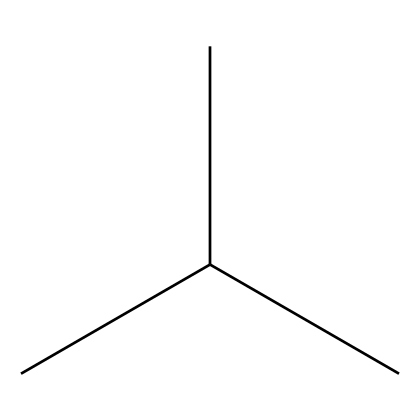What is the name of the chemical with the SMILES CC(C)C? The SMILES notation CC(C)C represents isobutane, which is a branched-chain alkane.
Answer: isobutane How many carbon atoms are in isobutane? The structure CC(C)C shows there are four carbon atoms when you count each "C" in the notation.
Answer: 4 What is the total number of hydrogen atoms in isobutane? Each carbon in isobutane is bonded appropriately, leading to a total of 10 hydrogen atoms. For alkanes, the formula is CnH(2n+2), where n=4.
Answer: 10 Is isobutane a gas or liquid at room temperature? Isobutane is a gas at room temperature, although it can be liquefied under pressure.
Answer: gas Why is isobutane used in small refrigeration units? Isobutane has favorable thermodynamic properties, such as low global warming potential and efficient heat absorption, making it suitable for refrigeration.
Answer: thermodynamic properties What type of chemical is isobutane classified as? Isobutane is classified as a refrigerant because it is commonly used in cooling systems and has a low environmental impact.
Answer: refrigerant What kind of bond exists between the carbon and hydrogen atoms in isobutane? The bonds between carbon and hydrogen in isobutane are single covalent bonds, indicating they share electron pairs.
Answer: single covalent bonds 